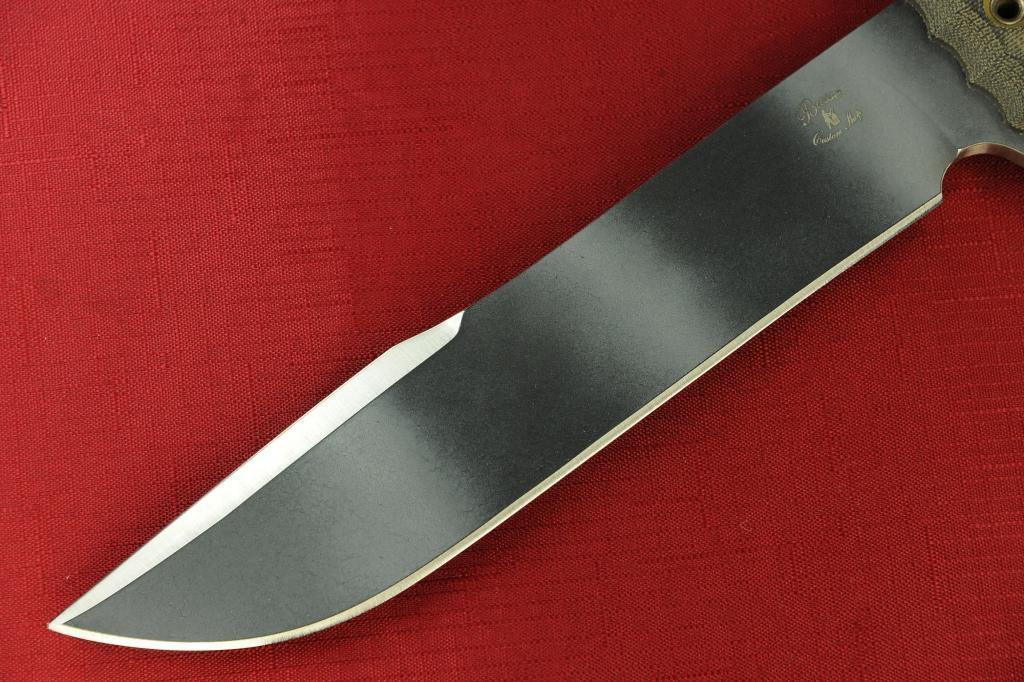Can you describe this image briefly? In this picture there is a knife which is kept on the red cloth. 